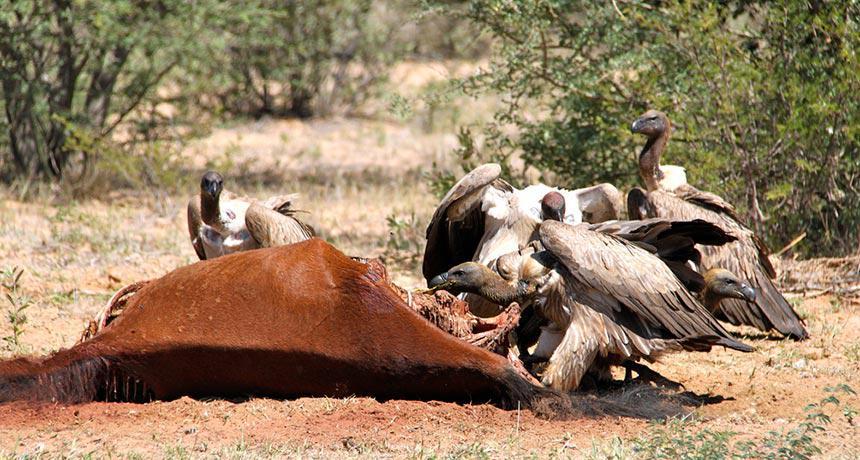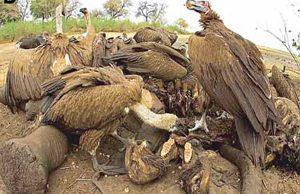The first image is the image on the left, the second image is the image on the right. Evaluate the accuracy of this statement regarding the images: "One of the meals is an antelope like creature, such as a deer.". Is it true? Answer yes or no. Yes. The first image is the image on the left, the second image is the image on the right. Examine the images to the left and right. Is the description "An image contains a mass of vultures and a living creature that is not a bird." accurate? Answer yes or no. No. 